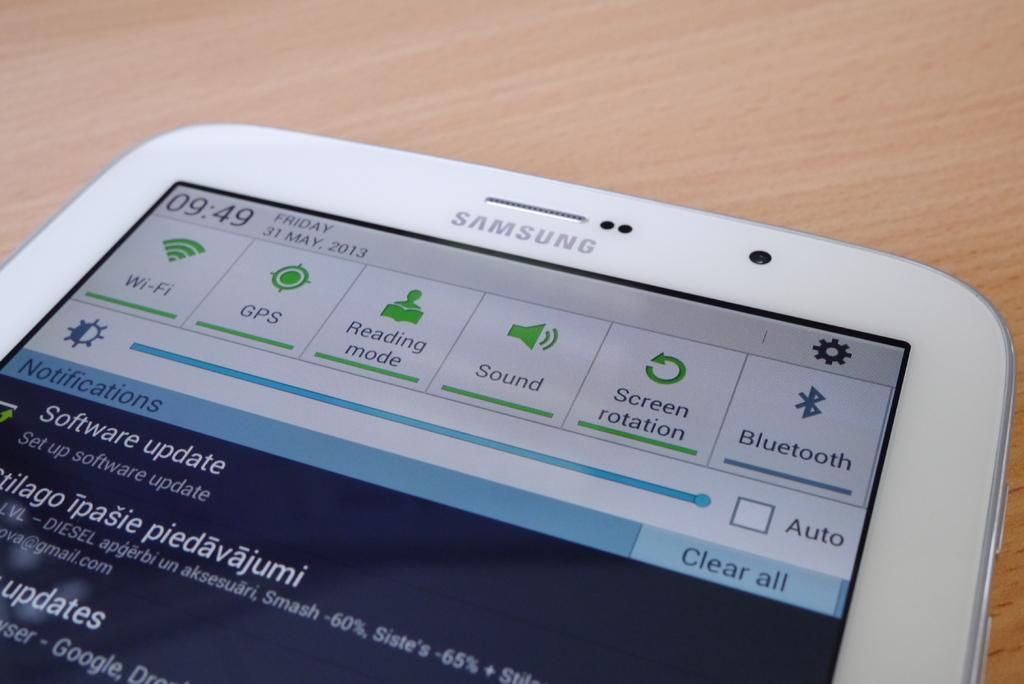What is the color of the mobile in the image? The mobile is white in the image. What type of surface is the mobile placed on? The mobile is placed on a wooden surface. What can be seen on the screen of the mobile? There are icons visible on the screen of the mobile. What type of card is placed on the table next to the mobile? There is no card or table present in the image; it only features a white color mobile placed on a wooden surface. 